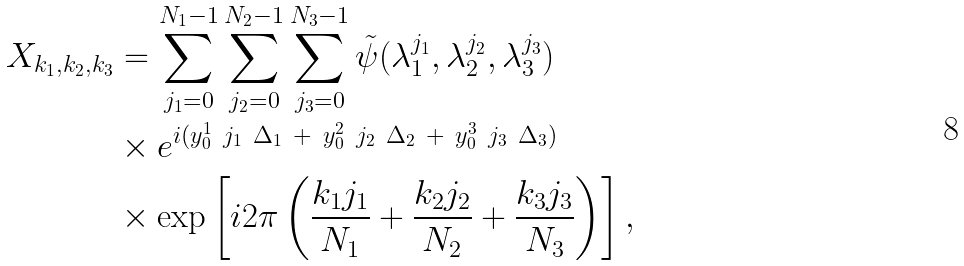Convert formula to latex. <formula><loc_0><loc_0><loc_500><loc_500>X _ { k _ { 1 } , k _ { 2 } , k _ { 3 } } & = \sum _ { j _ { 1 } = 0 } ^ { N _ { 1 } - 1 } \sum _ { j _ { 2 } = 0 } ^ { N _ { 2 } - 1 } \sum _ { j _ { 3 } = 0 } ^ { N _ { 3 } - 1 } \tilde { \psi } ( \lambda _ { 1 } ^ { j _ { 1 } } , \lambda _ { 2 } ^ { j _ { 2 } } , \lambda _ { 3 } ^ { j _ { 3 } } ) \\ & \times e ^ { i ( y _ { 0 } ^ { 1 } \ j _ { 1 } \ \Delta _ { 1 } \ + \ y _ { 0 } ^ { 2 } \ j _ { 2 } \ \Delta _ { 2 } \ + \ y _ { 0 } ^ { 3 } \ j _ { 3 } \ \Delta _ { 3 } ) } \\ & \times \exp \left [ i 2 \pi \left ( \frac { k _ { 1 } j _ { 1 } } { N _ { 1 } } + \frac { k _ { 2 } j _ { 2 } } { N _ { 2 } } + \frac { k _ { 3 } j _ { 3 } } { N _ { 3 } } \right ) \right ] ,</formula> 